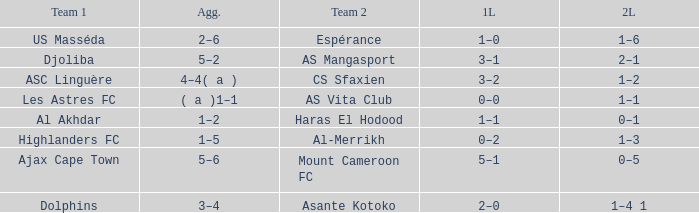What is the team 1 with team 2 Mount Cameroon FC? Ajax Cape Town. 